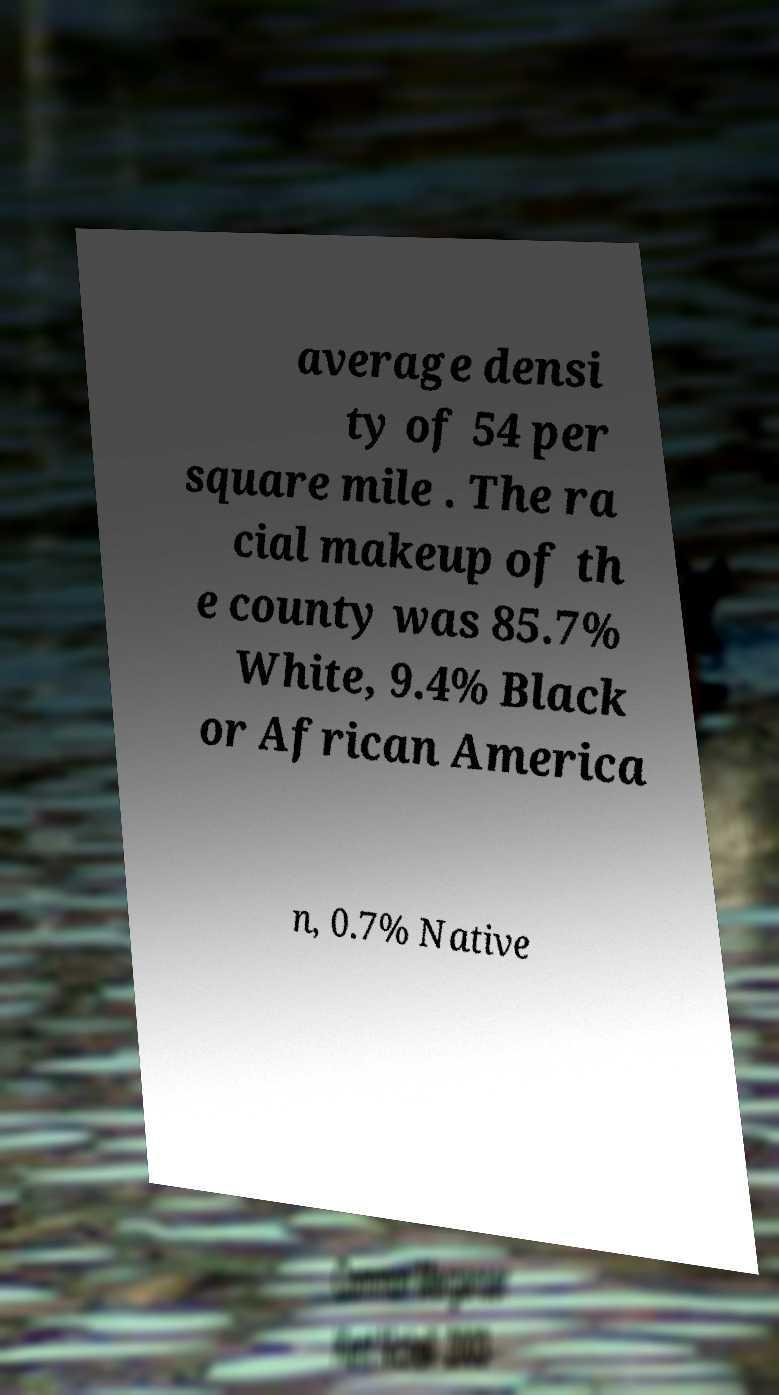There's text embedded in this image that I need extracted. Can you transcribe it verbatim? average densi ty of 54 per square mile . The ra cial makeup of th e county was 85.7% White, 9.4% Black or African America n, 0.7% Native 